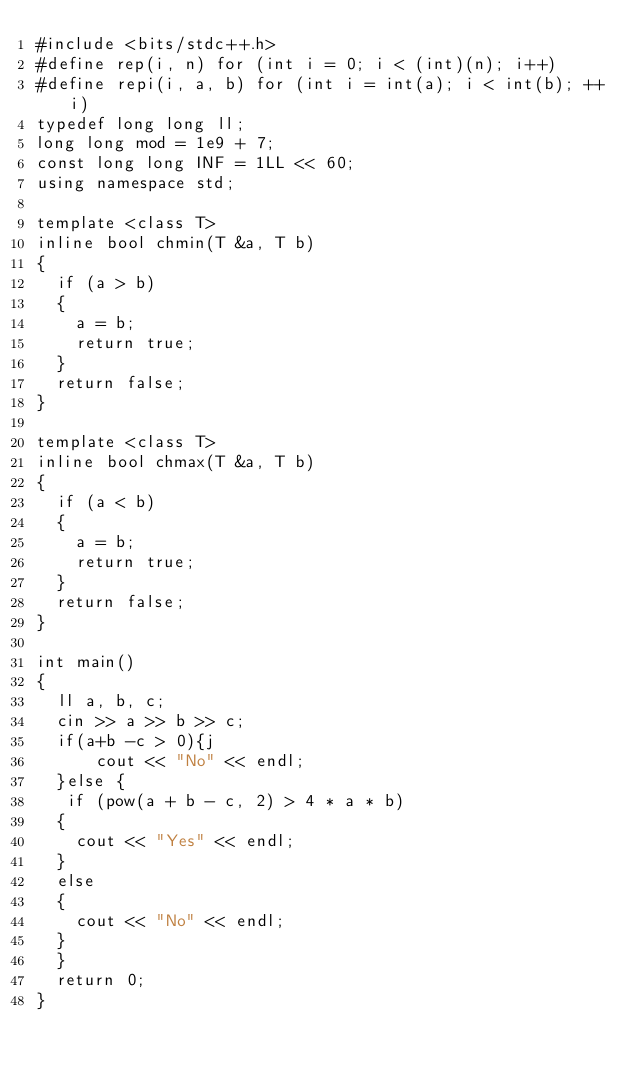<code> <loc_0><loc_0><loc_500><loc_500><_C++_>#include <bits/stdc++.h>
#define rep(i, n) for (int i = 0; i < (int)(n); i++)
#define repi(i, a, b) for (int i = int(a); i < int(b); ++i)
typedef long long ll;
long long mod = 1e9 + 7;
const long long INF = 1LL << 60;
using namespace std;

template <class T>
inline bool chmin(T &a, T b)
{
  if (a > b)
  {
    a = b;
    return true;
  }
  return false;
}

template <class T>
inline bool chmax(T &a, T b)
{
  if (a < b)
  {
    a = b;
    return true;
  }
  return false;
}

int main()
{
  ll a, b, c;
  cin >> a >> b >> c;
  if(a+b -c > 0){j
      cout << "No" << endl;
  }else {
   if (pow(a + b - c, 2) > 4 * a * b)
  {
    cout << "Yes" << endl;
  }
  else
  {
    cout << "No" << endl;
  } 
  }
  return 0;
}</code> 